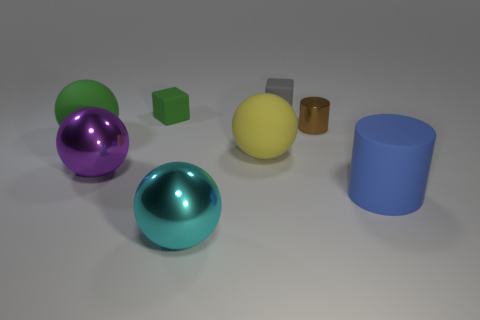Add 1 blue objects. How many objects exist? 9 Subtract all cyan balls. How many balls are left? 3 Subtract all green blocks. How many blocks are left? 1 Subtract 2 cylinders. How many cylinders are left? 0 Subtract all purple cylinders. Subtract all yellow blocks. How many cylinders are left? 2 Add 7 gray matte blocks. How many gray matte blocks are left? 8 Add 7 big brown metallic balls. How many big brown metallic balls exist? 7 Subtract 1 green balls. How many objects are left? 7 Subtract all cubes. How many objects are left? 6 Subtract all blue blocks. How many red balls are left? 0 